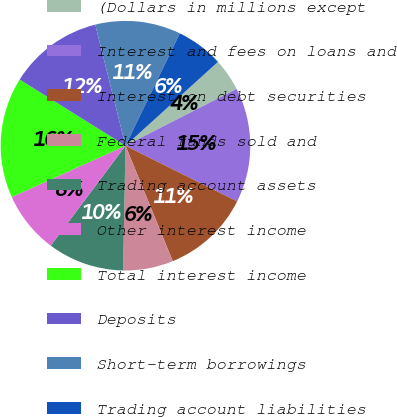Convert chart to OTSL. <chart><loc_0><loc_0><loc_500><loc_500><pie_chart><fcel>(Dollars in millions except<fcel>Interest and fees on loans and<fcel>Interest on debt securities<fcel>Federal funds sold and<fcel>Trading account assets<fcel>Other interest income<fcel>Total interest income<fcel>Deposits<fcel>Short-term borrowings<fcel>Trading account liabilities<nl><fcel>4.2%<fcel>14.89%<fcel>11.45%<fcel>6.49%<fcel>9.92%<fcel>8.02%<fcel>15.65%<fcel>12.21%<fcel>11.07%<fcel>6.11%<nl></chart> 